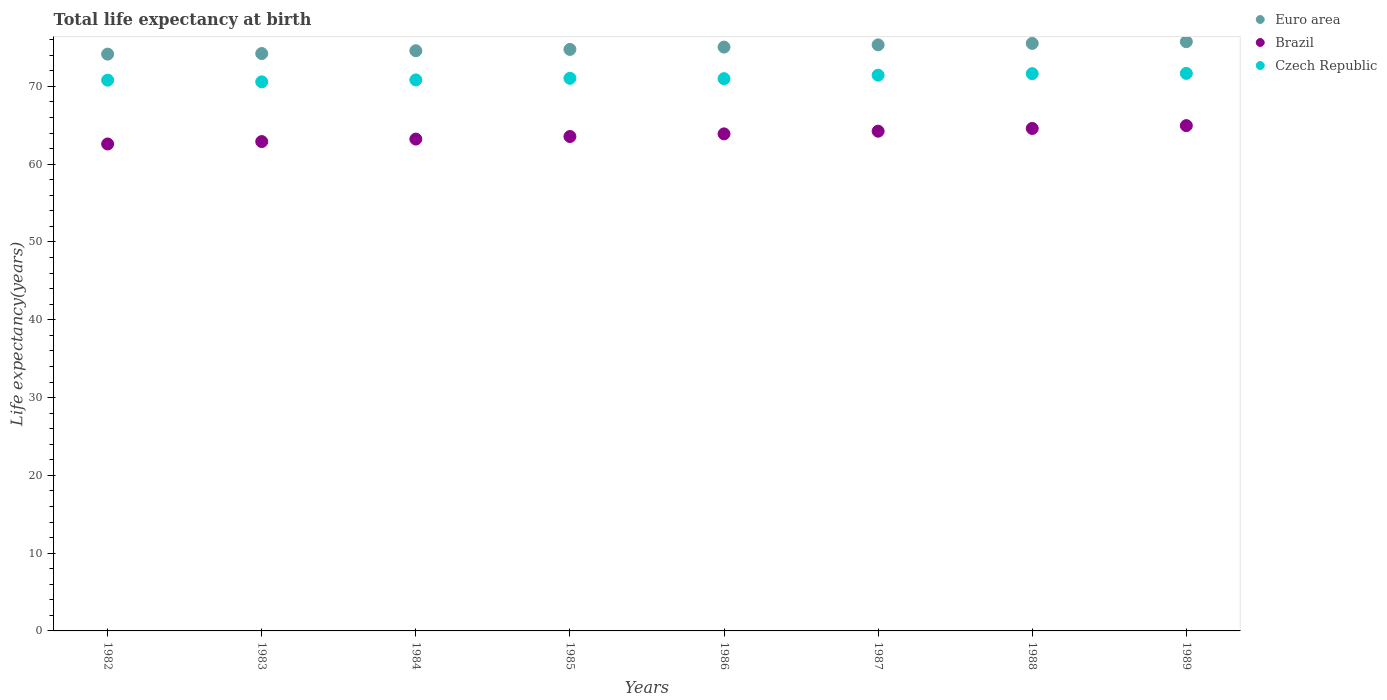How many different coloured dotlines are there?
Give a very brief answer. 3. What is the life expectancy at birth in in Czech Republic in 1989?
Your response must be concise. 71.68. Across all years, what is the maximum life expectancy at birth in in Euro area?
Your answer should be very brief. 75.75. Across all years, what is the minimum life expectancy at birth in in Czech Republic?
Offer a terse response. 70.59. In which year was the life expectancy at birth in in Euro area maximum?
Ensure brevity in your answer.  1989. What is the total life expectancy at birth in in Euro area in the graph?
Give a very brief answer. 599.41. What is the difference between the life expectancy at birth in in Czech Republic in 1982 and that in 1987?
Your answer should be compact. -0.64. What is the difference between the life expectancy at birth in in Czech Republic in 1985 and the life expectancy at birth in in Brazil in 1986?
Offer a terse response. 7.15. What is the average life expectancy at birth in in Czech Republic per year?
Provide a short and direct response. 71.13. In the year 1988, what is the difference between the life expectancy at birth in in Brazil and life expectancy at birth in in Euro area?
Your answer should be very brief. -10.93. What is the ratio of the life expectancy at birth in in Euro area in 1983 to that in 1989?
Ensure brevity in your answer.  0.98. What is the difference between the highest and the second highest life expectancy at birth in in Czech Republic?
Give a very brief answer. 0.03. What is the difference between the highest and the lowest life expectancy at birth in in Czech Republic?
Offer a very short reply. 1.08. In how many years, is the life expectancy at birth in in Czech Republic greater than the average life expectancy at birth in in Czech Republic taken over all years?
Give a very brief answer. 3. Is the sum of the life expectancy at birth in in Brazil in 1984 and 1987 greater than the maximum life expectancy at birth in in Euro area across all years?
Make the answer very short. Yes. How many dotlines are there?
Keep it short and to the point. 3. Are the values on the major ticks of Y-axis written in scientific E-notation?
Your answer should be very brief. No. Does the graph contain any zero values?
Your answer should be very brief. No. Does the graph contain grids?
Provide a short and direct response. No. Where does the legend appear in the graph?
Provide a succinct answer. Top right. How many legend labels are there?
Your answer should be compact. 3. How are the legend labels stacked?
Your answer should be very brief. Vertical. What is the title of the graph?
Your answer should be compact. Total life expectancy at birth. Does "Albania" appear as one of the legend labels in the graph?
Your answer should be compact. No. What is the label or title of the Y-axis?
Provide a short and direct response. Life expectancy(years). What is the Life expectancy(years) of Euro area in 1982?
Your answer should be compact. 74.15. What is the Life expectancy(years) in Brazil in 1982?
Ensure brevity in your answer.  62.6. What is the Life expectancy(years) in Czech Republic in 1982?
Give a very brief answer. 70.81. What is the Life expectancy(years) of Euro area in 1983?
Offer a very short reply. 74.23. What is the Life expectancy(years) in Brazil in 1983?
Ensure brevity in your answer.  62.91. What is the Life expectancy(years) of Czech Republic in 1983?
Provide a succinct answer. 70.59. What is the Life expectancy(years) of Euro area in 1984?
Provide a short and direct response. 74.59. What is the Life expectancy(years) in Brazil in 1984?
Provide a short and direct response. 63.23. What is the Life expectancy(years) of Czech Republic in 1984?
Provide a succinct answer. 70.84. What is the Life expectancy(years) in Euro area in 1985?
Provide a short and direct response. 74.76. What is the Life expectancy(years) of Brazil in 1985?
Offer a very short reply. 63.56. What is the Life expectancy(years) of Czech Republic in 1985?
Keep it short and to the point. 71.05. What is the Life expectancy(years) in Euro area in 1986?
Make the answer very short. 75.06. What is the Life expectancy(years) in Brazil in 1986?
Your response must be concise. 63.9. What is the Life expectancy(years) of Czech Republic in 1986?
Offer a very short reply. 71. What is the Life expectancy(years) of Euro area in 1987?
Your answer should be compact. 75.35. What is the Life expectancy(years) in Brazil in 1987?
Offer a very short reply. 64.25. What is the Life expectancy(years) of Czech Republic in 1987?
Provide a succinct answer. 71.45. What is the Life expectancy(years) in Euro area in 1988?
Offer a terse response. 75.53. What is the Life expectancy(years) of Brazil in 1988?
Ensure brevity in your answer.  64.6. What is the Life expectancy(years) in Czech Republic in 1988?
Your response must be concise. 71.64. What is the Life expectancy(years) in Euro area in 1989?
Offer a very short reply. 75.75. What is the Life expectancy(years) of Brazil in 1989?
Your answer should be compact. 64.96. What is the Life expectancy(years) of Czech Republic in 1989?
Your answer should be compact. 71.68. Across all years, what is the maximum Life expectancy(years) in Euro area?
Make the answer very short. 75.75. Across all years, what is the maximum Life expectancy(years) in Brazil?
Provide a succinct answer. 64.96. Across all years, what is the maximum Life expectancy(years) of Czech Republic?
Keep it short and to the point. 71.68. Across all years, what is the minimum Life expectancy(years) of Euro area?
Provide a succinct answer. 74.15. Across all years, what is the minimum Life expectancy(years) of Brazil?
Keep it short and to the point. 62.6. Across all years, what is the minimum Life expectancy(years) in Czech Republic?
Keep it short and to the point. 70.59. What is the total Life expectancy(years) of Euro area in the graph?
Provide a succinct answer. 599.41. What is the total Life expectancy(years) of Brazil in the graph?
Give a very brief answer. 510.01. What is the total Life expectancy(years) of Czech Republic in the graph?
Provide a succinct answer. 569.04. What is the difference between the Life expectancy(years) of Euro area in 1982 and that in 1983?
Ensure brevity in your answer.  -0.08. What is the difference between the Life expectancy(years) in Brazil in 1982 and that in 1983?
Provide a succinct answer. -0.31. What is the difference between the Life expectancy(years) of Czech Republic in 1982 and that in 1983?
Keep it short and to the point. 0.22. What is the difference between the Life expectancy(years) of Euro area in 1982 and that in 1984?
Give a very brief answer. -0.43. What is the difference between the Life expectancy(years) in Brazil in 1982 and that in 1984?
Keep it short and to the point. -0.63. What is the difference between the Life expectancy(years) of Czech Republic in 1982 and that in 1984?
Your answer should be compact. -0.03. What is the difference between the Life expectancy(years) in Euro area in 1982 and that in 1985?
Provide a succinct answer. -0.6. What is the difference between the Life expectancy(years) in Brazil in 1982 and that in 1985?
Provide a short and direct response. -0.96. What is the difference between the Life expectancy(years) in Czech Republic in 1982 and that in 1985?
Give a very brief answer. -0.24. What is the difference between the Life expectancy(years) of Euro area in 1982 and that in 1986?
Offer a terse response. -0.9. What is the difference between the Life expectancy(years) of Brazil in 1982 and that in 1986?
Your response must be concise. -1.3. What is the difference between the Life expectancy(years) of Czech Republic in 1982 and that in 1986?
Your answer should be very brief. -0.19. What is the difference between the Life expectancy(years) of Euro area in 1982 and that in 1987?
Your answer should be compact. -1.19. What is the difference between the Life expectancy(years) in Brazil in 1982 and that in 1987?
Your answer should be very brief. -1.64. What is the difference between the Life expectancy(years) of Czech Republic in 1982 and that in 1987?
Your answer should be compact. -0.64. What is the difference between the Life expectancy(years) in Euro area in 1982 and that in 1988?
Your answer should be very brief. -1.38. What is the difference between the Life expectancy(years) in Brazil in 1982 and that in 1988?
Ensure brevity in your answer.  -2. What is the difference between the Life expectancy(years) of Czech Republic in 1982 and that in 1988?
Make the answer very short. -0.83. What is the difference between the Life expectancy(years) in Euro area in 1982 and that in 1989?
Provide a short and direct response. -1.6. What is the difference between the Life expectancy(years) in Brazil in 1982 and that in 1989?
Offer a terse response. -2.36. What is the difference between the Life expectancy(years) in Czech Republic in 1982 and that in 1989?
Ensure brevity in your answer.  -0.87. What is the difference between the Life expectancy(years) of Euro area in 1983 and that in 1984?
Your answer should be compact. -0.36. What is the difference between the Life expectancy(years) of Brazil in 1983 and that in 1984?
Offer a terse response. -0.32. What is the difference between the Life expectancy(years) in Czech Republic in 1983 and that in 1984?
Offer a very short reply. -0.25. What is the difference between the Life expectancy(years) of Euro area in 1983 and that in 1985?
Ensure brevity in your answer.  -0.53. What is the difference between the Life expectancy(years) in Brazil in 1983 and that in 1985?
Ensure brevity in your answer.  -0.65. What is the difference between the Life expectancy(years) in Czech Republic in 1983 and that in 1985?
Your response must be concise. -0.45. What is the difference between the Life expectancy(years) in Euro area in 1983 and that in 1986?
Keep it short and to the point. -0.83. What is the difference between the Life expectancy(years) in Brazil in 1983 and that in 1986?
Make the answer very short. -0.99. What is the difference between the Life expectancy(years) in Czech Republic in 1983 and that in 1986?
Ensure brevity in your answer.  -0.41. What is the difference between the Life expectancy(years) of Euro area in 1983 and that in 1987?
Your answer should be very brief. -1.12. What is the difference between the Life expectancy(years) of Brazil in 1983 and that in 1987?
Your answer should be very brief. -1.33. What is the difference between the Life expectancy(years) in Czech Republic in 1983 and that in 1987?
Offer a terse response. -0.85. What is the difference between the Life expectancy(years) in Euro area in 1983 and that in 1988?
Give a very brief answer. -1.3. What is the difference between the Life expectancy(years) in Brazil in 1983 and that in 1988?
Offer a terse response. -1.69. What is the difference between the Life expectancy(years) in Czech Republic in 1983 and that in 1988?
Give a very brief answer. -1.05. What is the difference between the Life expectancy(years) of Euro area in 1983 and that in 1989?
Ensure brevity in your answer.  -1.52. What is the difference between the Life expectancy(years) in Brazil in 1983 and that in 1989?
Keep it short and to the point. -2.05. What is the difference between the Life expectancy(years) of Czech Republic in 1983 and that in 1989?
Ensure brevity in your answer.  -1.08. What is the difference between the Life expectancy(years) in Euro area in 1984 and that in 1985?
Provide a short and direct response. -0.17. What is the difference between the Life expectancy(years) in Brazil in 1984 and that in 1985?
Your answer should be very brief. -0.33. What is the difference between the Life expectancy(years) of Czech Republic in 1984 and that in 1985?
Your response must be concise. -0.21. What is the difference between the Life expectancy(years) of Euro area in 1984 and that in 1986?
Offer a terse response. -0.47. What is the difference between the Life expectancy(years) of Brazil in 1984 and that in 1986?
Ensure brevity in your answer.  -0.67. What is the difference between the Life expectancy(years) of Czech Republic in 1984 and that in 1986?
Give a very brief answer. -0.16. What is the difference between the Life expectancy(years) in Euro area in 1984 and that in 1987?
Make the answer very short. -0.76. What is the difference between the Life expectancy(years) in Brazil in 1984 and that in 1987?
Provide a succinct answer. -1.01. What is the difference between the Life expectancy(years) of Czech Republic in 1984 and that in 1987?
Your answer should be very brief. -0.61. What is the difference between the Life expectancy(years) of Euro area in 1984 and that in 1988?
Ensure brevity in your answer.  -0.94. What is the difference between the Life expectancy(years) in Brazil in 1984 and that in 1988?
Your response must be concise. -1.37. What is the difference between the Life expectancy(years) in Czech Republic in 1984 and that in 1988?
Give a very brief answer. -0.8. What is the difference between the Life expectancy(years) of Euro area in 1984 and that in 1989?
Offer a very short reply. -1.16. What is the difference between the Life expectancy(years) of Brazil in 1984 and that in 1989?
Your answer should be compact. -1.73. What is the difference between the Life expectancy(years) in Czech Republic in 1984 and that in 1989?
Your answer should be very brief. -0.84. What is the difference between the Life expectancy(years) in Euro area in 1985 and that in 1986?
Your answer should be compact. -0.3. What is the difference between the Life expectancy(years) in Brazil in 1985 and that in 1986?
Offer a very short reply. -0.34. What is the difference between the Life expectancy(years) in Czech Republic in 1985 and that in 1986?
Ensure brevity in your answer.  0.05. What is the difference between the Life expectancy(years) in Euro area in 1985 and that in 1987?
Keep it short and to the point. -0.59. What is the difference between the Life expectancy(years) in Brazil in 1985 and that in 1987?
Give a very brief answer. -0.68. What is the difference between the Life expectancy(years) of Czech Republic in 1985 and that in 1987?
Give a very brief answer. -0.4. What is the difference between the Life expectancy(years) in Euro area in 1985 and that in 1988?
Make the answer very short. -0.77. What is the difference between the Life expectancy(years) of Brazil in 1985 and that in 1988?
Make the answer very short. -1.04. What is the difference between the Life expectancy(years) in Czech Republic in 1985 and that in 1988?
Ensure brevity in your answer.  -0.6. What is the difference between the Life expectancy(years) of Euro area in 1985 and that in 1989?
Keep it short and to the point. -0.99. What is the difference between the Life expectancy(years) in Brazil in 1985 and that in 1989?
Ensure brevity in your answer.  -1.4. What is the difference between the Life expectancy(years) in Czech Republic in 1985 and that in 1989?
Your answer should be compact. -0.63. What is the difference between the Life expectancy(years) in Euro area in 1986 and that in 1987?
Provide a short and direct response. -0.29. What is the difference between the Life expectancy(years) in Brazil in 1986 and that in 1987?
Provide a succinct answer. -0.35. What is the difference between the Life expectancy(years) of Czech Republic in 1986 and that in 1987?
Give a very brief answer. -0.45. What is the difference between the Life expectancy(years) in Euro area in 1986 and that in 1988?
Give a very brief answer. -0.47. What is the difference between the Life expectancy(years) in Brazil in 1986 and that in 1988?
Give a very brief answer. -0.7. What is the difference between the Life expectancy(years) of Czech Republic in 1986 and that in 1988?
Your answer should be very brief. -0.64. What is the difference between the Life expectancy(years) of Euro area in 1986 and that in 1989?
Offer a terse response. -0.7. What is the difference between the Life expectancy(years) in Brazil in 1986 and that in 1989?
Your response must be concise. -1.06. What is the difference between the Life expectancy(years) of Czech Republic in 1986 and that in 1989?
Keep it short and to the point. -0.68. What is the difference between the Life expectancy(years) in Euro area in 1987 and that in 1988?
Your answer should be very brief. -0.18. What is the difference between the Life expectancy(years) of Brazil in 1987 and that in 1988?
Your answer should be very brief. -0.35. What is the difference between the Life expectancy(years) in Czech Republic in 1987 and that in 1988?
Your answer should be compact. -0.2. What is the difference between the Life expectancy(years) of Euro area in 1987 and that in 1989?
Ensure brevity in your answer.  -0.41. What is the difference between the Life expectancy(years) in Brazil in 1987 and that in 1989?
Make the answer very short. -0.72. What is the difference between the Life expectancy(years) of Czech Republic in 1987 and that in 1989?
Your answer should be compact. -0.23. What is the difference between the Life expectancy(years) in Euro area in 1988 and that in 1989?
Your answer should be compact. -0.22. What is the difference between the Life expectancy(years) of Brazil in 1988 and that in 1989?
Ensure brevity in your answer.  -0.36. What is the difference between the Life expectancy(years) in Czech Republic in 1988 and that in 1989?
Your answer should be very brief. -0.03. What is the difference between the Life expectancy(years) in Euro area in 1982 and the Life expectancy(years) in Brazil in 1983?
Give a very brief answer. 11.24. What is the difference between the Life expectancy(years) in Euro area in 1982 and the Life expectancy(years) in Czech Republic in 1983?
Provide a short and direct response. 3.56. What is the difference between the Life expectancy(years) in Brazil in 1982 and the Life expectancy(years) in Czech Republic in 1983?
Keep it short and to the point. -7.99. What is the difference between the Life expectancy(years) of Euro area in 1982 and the Life expectancy(years) of Brazil in 1984?
Provide a succinct answer. 10.92. What is the difference between the Life expectancy(years) in Euro area in 1982 and the Life expectancy(years) in Czech Republic in 1984?
Make the answer very short. 3.32. What is the difference between the Life expectancy(years) of Brazil in 1982 and the Life expectancy(years) of Czech Republic in 1984?
Provide a succinct answer. -8.24. What is the difference between the Life expectancy(years) in Euro area in 1982 and the Life expectancy(years) in Brazil in 1985?
Ensure brevity in your answer.  10.59. What is the difference between the Life expectancy(years) of Euro area in 1982 and the Life expectancy(years) of Czech Republic in 1985?
Give a very brief answer. 3.11. What is the difference between the Life expectancy(years) of Brazil in 1982 and the Life expectancy(years) of Czech Republic in 1985?
Keep it short and to the point. -8.44. What is the difference between the Life expectancy(years) of Euro area in 1982 and the Life expectancy(years) of Brazil in 1986?
Keep it short and to the point. 10.25. What is the difference between the Life expectancy(years) of Euro area in 1982 and the Life expectancy(years) of Czech Republic in 1986?
Your answer should be compact. 3.16. What is the difference between the Life expectancy(years) in Brazil in 1982 and the Life expectancy(years) in Czech Republic in 1986?
Give a very brief answer. -8.4. What is the difference between the Life expectancy(years) in Euro area in 1982 and the Life expectancy(years) in Brazil in 1987?
Make the answer very short. 9.91. What is the difference between the Life expectancy(years) in Euro area in 1982 and the Life expectancy(years) in Czech Republic in 1987?
Provide a succinct answer. 2.71. What is the difference between the Life expectancy(years) in Brazil in 1982 and the Life expectancy(years) in Czech Republic in 1987?
Ensure brevity in your answer.  -8.84. What is the difference between the Life expectancy(years) of Euro area in 1982 and the Life expectancy(years) of Brazil in 1988?
Provide a succinct answer. 9.56. What is the difference between the Life expectancy(years) in Euro area in 1982 and the Life expectancy(years) in Czech Republic in 1988?
Make the answer very short. 2.51. What is the difference between the Life expectancy(years) in Brazil in 1982 and the Life expectancy(years) in Czech Republic in 1988?
Give a very brief answer. -9.04. What is the difference between the Life expectancy(years) in Euro area in 1982 and the Life expectancy(years) in Brazil in 1989?
Offer a very short reply. 9.19. What is the difference between the Life expectancy(years) in Euro area in 1982 and the Life expectancy(years) in Czech Republic in 1989?
Your response must be concise. 2.48. What is the difference between the Life expectancy(years) of Brazil in 1982 and the Life expectancy(years) of Czech Republic in 1989?
Provide a succinct answer. -9.07. What is the difference between the Life expectancy(years) in Euro area in 1983 and the Life expectancy(years) in Brazil in 1984?
Give a very brief answer. 11. What is the difference between the Life expectancy(years) of Euro area in 1983 and the Life expectancy(years) of Czech Republic in 1984?
Keep it short and to the point. 3.39. What is the difference between the Life expectancy(years) in Brazil in 1983 and the Life expectancy(years) in Czech Republic in 1984?
Keep it short and to the point. -7.93. What is the difference between the Life expectancy(years) in Euro area in 1983 and the Life expectancy(years) in Brazil in 1985?
Ensure brevity in your answer.  10.67. What is the difference between the Life expectancy(years) of Euro area in 1983 and the Life expectancy(years) of Czech Republic in 1985?
Offer a very short reply. 3.18. What is the difference between the Life expectancy(years) of Brazil in 1983 and the Life expectancy(years) of Czech Republic in 1985?
Offer a very short reply. -8.13. What is the difference between the Life expectancy(years) in Euro area in 1983 and the Life expectancy(years) in Brazil in 1986?
Your answer should be compact. 10.33. What is the difference between the Life expectancy(years) of Euro area in 1983 and the Life expectancy(years) of Czech Republic in 1986?
Give a very brief answer. 3.23. What is the difference between the Life expectancy(years) of Brazil in 1983 and the Life expectancy(years) of Czech Republic in 1986?
Your response must be concise. -8.09. What is the difference between the Life expectancy(years) of Euro area in 1983 and the Life expectancy(years) of Brazil in 1987?
Ensure brevity in your answer.  9.98. What is the difference between the Life expectancy(years) of Euro area in 1983 and the Life expectancy(years) of Czech Republic in 1987?
Ensure brevity in your answer.  2.78. What is the difference between the Life expectancy(years) of Brazil in 1983 and the Life expectancy(years) of Czech Republic in 1987?
Your answer should be very brief. -8.53. What is the difference between the Life expectancy(years) in Euro area in 1983 and the Life expectancy(years) in Brazil in 1988?
Your answer should be compact. 9.63. What is the difference between the Life expectancy(years) of Euro area in 1983 and the Life expectancy(years) of Czech Republic in 1988?
Offer a very short reply. 2.59. What is the difference between the Life expectancy(years) of Brazil in 1983 and the Life expectancy(years) of Czech Republic in 1988?
Make the answer very short. -8.73. What is the difference between the Life expectancy(years) in Euro area in 1983 and the Life expectancy(years) in Brazil in 1989?
Make the answer very short. 9.27. What is the difference between the Life expectancy(years) of Euro area in 1983 and the Life expectancy(years) of Czech Republic in 1989?
Give a very brief answer. 2.55. What is the difference between the Life expectancy(years) in Brazil in 1983 and the Life expectancy(years) in Czech Republic in 1989?
Offer a terse response. -8.76. What is the difference between the Life expectancy(years) of Euro area in 1984 and the Life expectancy(years) of Brazil in 1985?
Provide a succinct answer. 11.03. What is the difference between the Life expectancy(years) in Euro area in 1984 and the Life expectancy(years) in Czech Republic in 1985?
Provide a short and direct response. 3.54. What is the difference between the Life expectancy(years) of Brazil in 1984 and the Life expectancy(years) of Czech Republic in 1985?
Give a very brief answer. -7.81. What is the difference between the Life expectancy(years) in Euro area in 1984 and the Life expectancy(years) in Brazil in 1986?
Offer a very short reply. 10.69. What is the difference between the Life expectancy(years) of Euro area in 1984 and the Life expectancy(years) of Czech Republic in 1986?
Give a very brief answer. 3.59. What is the difference between the Life expectancy(years) of Brazil in 1984 and the Life expectancy(years) of Czech Republic in 1986?
Ensure brevity in your answer.  -7.77. What is the difference between the Life expectancy(years) in Euro area in 1984 and the Life expectancy(years) in Brazil in 1987?
Provide a short and direct response. 10.34. What is the difference between the Life expectancy(years) in Euro area in 1984 and the Life expectancy(years) in Czech Republic in 1987?
Make the answer very short. 3.14. What is the difference between the Life expectancy(years) in Brazil in 1984 and the Life expectancy(years) in Czech Republic in 1987?
Offer a terse response. -8.21. What is the difference between the Life expectancy(years) of Euro area in 1984 and the Life expectancy(years) of Brazil in 1988?
Your response must be concise. 9.99. What is the difference between the Life expectancy(years) of Euro area in 1984 and the Life expectancy(years) of Czech Republic in 1988?
Make the answer very short. 2.95. What is the difference between the Life expectancy(years) in Brazil in 1984 and the Life expectancy(years) in Czech Republic in 1988?
Your response must be concise. -8.41. What is the difference between the Life expectancy(years) of Euro area in 1984 and the Life expectancy(years) of Brazil in 1989?
Offer a very short reply. 9.63. What is the difference between the Life expectancy(years) in Euro area in 1984 and the Life expectancy(years) in Czech Republic in 1989?
Provide a succinct answer. 2.91. What is the difference between the Life expectancy(years) in Brazil in 1984 and the Life expectancy(years) in Czech Republic in 1989?
Make the answer very short. -8.44. What is the difference between the Life expectancy(years) in Euro area in 1985 and the Life expectancy(years) in Brazil in 1986?
Your answer should be compact. 10.86. What is the difference between the Life expectancy(years) of Euro area in 1985 and the Life expectancy(years) of Czech Republic in 1986?
Your answer should be very brief. 3.76. What is the difference between the Life expectancy(years) of Brazil in 1985 and the Life expectancy(years) of Czech Republic in 1986?
Provide a succinct answer. -7.43. What is the difference between the Life expectancy(years) of Euro area in 1985 and the Life expectancy(years) of Brazil in 1987?
Offer a terse response. 10.51. What is the difference between the Life expectancy(years) in Euro area in 1985 and the Life expectancy(years) in Czech Republic in 1987?
Make the answer very short. 3.31. What is the difference between the Life expectancy(years) in Brazil in 1985 and the Life expectancy(years) in Czech Republic in 1987?
Give a very brief answer. -7.88. What is the difference between the Life expectancy(years) of Euro area in 1985 and the Life expectancy(years) of Brazil in 1988?
Make the answer very short. 10.16. What is the difference between the Life expectancy(years) of Euro area in 1985 and the Life expectancy(years) of Czech Republic in 1988?
Give a very brief answer. 3.12. What is the difference between the Life expectancy(years) in Brazil in 1985 and the Life expectancy(years) in Czech Republic in 1988?
Keep it short and to the point. -8.08. What is the difference between the Life expectancy(years) of Euro area in 1985 and the Life expectancy(years) of Brazil in 1989?
Ensure brevity in your answer.  9.8. What is the difference between the Life expectancy(years) of Euro area in 1985 and the Life expectancy(years) of Czech Republic in 1989?
Your response must be concise. 3.08. What is the difference between the Life expectancy(years) of Brazil in 1985 and the Life expectancy(years) of Czech Republic in 1989?
Your response must be concise. -8.11. What is the difference between the Life expectancy(years) in Euro area in 1986 and the Life expectancy(years) in Brazil in 1987?
Ensure brevity in your answer.  10.81. What is the difference between the Life expectancy(years) in Euro area in 1986 and the Life expectancy(years) in Czech Republic in 1987?
Your answer should be very brief. 3.61. What is the difference between the Life expectancy(years) in Brazil in 1986 and the Life expectancy(years) in Czech Republic in 1987?
Give a very brief answer. -7.55. What is the difference between the Life expectancy(years) in Euro area in 1986 and the Life expectancy(years) in Brazil in 1988?
Your answer should be compact. 10.46. What is the difference between the Life expectancy(years) in Euro area in 1986 and the Life expectancy(years) in Czech Republic in 1988?
Offer a terse response. 3.42. What is the difference between the Life expectancy(years) in Brazil in 1986 and the Life expectancy(years) in Czech Republic in 1988?
Provide a short and direct response. -7.74. What is the difference between the Life expectancy(years) of Euro area in 1986 and the Life expectancy(years) of Brazil in 1989?
Give a very brief answer. 10.1. What is the difference between the Life expectancy(years) of Euro area in 1986 and the Life expectancy(years) of Czech Republic in 1989?
Ensure brevity in your answer.  3.38. What is the difference between the Life expectancy(years) in Brazil in 1986 and the Life expectancy(years) in Czech Republic in 1989?
Provide a short and direct response. -7.78. What is the difference between the Life expectancy(years) of Euro area in 1987 and the Life expectancy(years) of Brazil in 1988?
Your response must be concise. 10.75. What is the difference between the Life expectancy(years) in Euro area in 1987 and the Life expectancy(years) in Czech Republic in 1988?
Offer a terse response. 3.7. What is the difference between the Life expectancy(years) in Brazil in 1987 and the Life expectancy(years) in Czech Republic in 1988?
Your answer should be very brief. -7.4. What is the difference between the Life expectancy(years) in Euro area in 1987 and the Life expectancy(years) in Brazil in 1989?
Your response must be concise. 10.38. What is the difference between the Life expectancy(years) of Euro area in 1987 and the Life expectancy(years) of Czech Republic in 1989?
Provide a succinct answer. 3.67. What is the difference between the Life expectancy(years) of Brazil in 1987 and the Life expectancy(years) of Czech Republic in 1989?
Provide a succinct answer. -7.43. What is the difference between the Life expectancy(years) in Euro area in 1988 and the Life expectancy(years) in Brazil in 1989?
Make the answer very short. 10.57. What is the difference between the Life expectancy(years) in Euro area in 1988 and the Life expectancy(years) in Czech Republic in 1989?
Make the answer very short. 3.85. What is the difference between the Life expectancy(years) in Brazil in 1988 and the Life expectancy(years) in Czech Republic in 1989?
Offer a terse response. -7.08. What is the average Life expectancy(years) in Euro area per year?
Your answer should be compact. 74.93. What is the average Life expectancy(years) in Brazil per year?
Your answer should be very brief. 63.75. What is the average Life expectancy(years) of Czech Republic per year?
Make the answer very short. 71.13. In the year 1982, what is the difference between the Life expectancy(years) of Euro area and Life expectancy(years) of Brazil?
Your answer should be very brief. 11.55. In the year 1982, what is the difference between the Life expectancy(years) of Euro area and Life expectancy(years) of Czech Republic?
Offer a very short reply. 3.35. In the year 1982, what is the difference between the Life expectancy(years) of Brazil and Life expectancy(years) of Czech Republic?
Provide a succinct answer. -8.21. In the year 1983, what is the difference between the Life expectancy(years) in Euro area and Life expectancy(years) in Brazil?
Your response must be concise. 11.32. In the year 1983, what is the difference between the Life expectancy(years) of Euro area and Life expectancy(years) of Czech Republic?
Give a very brief answer. 3.64. In the year 1983, what is the difference between the Life expectancy(years) of Brazil and Life expectancy(years) of Czech Republic?
Give a very brief answer. -7.68. In the year 1984, what is the difference between the Life expectancy(years) in Euro area and Life expectancy(years) in Brazil?
Make the answer very short. 11.36. In the year 1984, what is the difference between the Life expectancy(years) of Euro area and Life expectancy(years) of Czech Republic?
Give a very brief answer. 3.75. In the year 1984, what is the difference between the Life expectancy(years) in Brazil and Life expectancy(years) in Czech Republic?
Provide a short and direct response. -7.61. In the year 1985, what is the difference between the Life expectancy(years) in Euro area and Life expectancy(years) in Brazil?
Ensure brevity in your answer.  11.2. In the year 1985, what is the difference between the Life expectancy(years) of Euro area and Life expectancy(years) of Czech Republic?
Offer a terse response. 3.71. In the year 1985, what is the difference between the Life expectancy(years) in Brazil and Life expectancy(years) in Czech Republic?
Offer a very short reply. -7.48. In the year 1986, what is the difference between the Life expectancy(years) of Euro area and Life expectancy(years) of Brazil?
Make the answer very short. 11.16. In the year 1986, what is the difference between the Life expectancy(years) in Euro area and Life expectancy(years) in Czech Republic?
Make the answer very short. 4.06. In the year 1986, what is the difference between the Life expectancy(years) of Brazil and Life expectancy(years) of Czech Republic?
Offer a terse response. -7.1. In the year 1987, what is the difference between the Life expectancy(years) in Euro area and Life expectancy(years) in Brazil?
Your answer should be very brief. 11.1. In the year 1987, what is the difference between the Life expectancy(years) of Euro area and Life expectancy(years) of Czech Republic?
Make the answer very short. 3.9. In the year 1987, what is the difference between the Life expectancy(years) in Brazil and Life expectancy(years) in Czech Republic?
Provide a succinct answer. -7.2. In the year 1988, what is the difference between the Life expectancy(years) of Euro area and Life expectancy(years) of Brazil?
Your answer should be compact. 10.93. In the year 1988, what is the difference between the Life expectancy(years) of Euro area and Life expectancy(years) of Czech Republic?
Offer a very short reply. 3.89. In the year 1988, what is the difference between the Life expectancy(years) in Brazil and Life expectancy(years) in Czech Republic?
Your answer should be very brief. -7.04. In the year 1989, what is the difference between the Life expectancy(years) in Euro area and Life expectancy(years) in Brazil?
Keep it short and to the point. 10.79. In the year 1989, what is the difference between the Life expectancy(years) in Euro area and Life expectancy(years) in Czech Republic?
Ensure brevity in your answer.  4.08. In the year 1989, what is the difference between the Life expectancy(years) in Brazil and Life expectancy(years) in Czech Republic?
Offer a very short reply. -6.71. What is the ratio of the Life expectancy(years) of Brazil in 1982 to that in 1983?
Your answer should be compact. 1. What is the ratio of the Life expectancy(years) in Euro area in 1982 to that in 1984?
Your response must be concise. 0.99. What is the ratio of the Life expectancy(years) in Brazil in 1982 to that in 1984?
Make the answer very short. 0.99. What is the ratio of the Life expectancy(years) of Czech Republic in 1982 to that in 1984?
Provide a succinct answer. 1. What is the ratio of the Life expectancy(years) of Brazil in 1982 to that in 1985?
Your response must be concise. 0.98. What is the ratio of the Life expectancy(years) of Brazil in 1982 to that in 1986?
Your response must be concise. 0.98. What is the ratio of the Life expectancy(years) of Czech Republic in 1982 to that in 1986?
Provide a short and direct response. 1. What is the ratio of the Life expectancy(years) in Euro area in 1982 to that in 1987?
Your answer should be very brief. 0.98. What is the ratio of the Life expectancy(years) of Brazil in 1982 to that in 1987?
Make the answer very short. 0.97. What is the ratio of the Life expectancy(years) of Czech Republic in 1982 to that in 1987?
Offer a very short reply. 0.99. What is the ratio of the Life expectancy(years) in Euro area in 1982 to that in 1988?
Your answer should be compact. 0.98. What is the ratio of the Life expectancy(years) of Brazil in 1982 to that in 1988?
Your response must be concise. 0.97. What is the ratio of the Life expectancy(years) of Czech Republic in 1982 to that in 1988?
Offer a very short reply. 0.99. What is the ratio of the Life expectancy(years) of Euro area in 1982 to that in 1989?
Give a very brief answer. 0.98. What is the ratio of the Life expectancy(years) in Brazil in 1982 to that in 1989?
Ensure brevity in your answer.  0.96. What is the ratio of the Life expectancy(years) in Czech Republic in 1982 to that in 1989?
Make the answer very short. 0.99. What is the ratio of the Life expectancy(years) of Brazil in 1983 to that in 1984?
Make the answer very short. 0.99. What is the ratio of the Life expectancy(years) in Czech Republic in 1983 to that in 1984?
Give a very brief answer. 1. What is the ratio of the Life expectancy(years) in Czech Republic in 1983 to that in 1985?
Your response must be concise. 0.99. What is the ratio of the Life expectancy(years) in Brazil in 1983 to that in 1986?
Offer a terse response. 0.98. What is the ratio of the Life expectancy(years) of Czech Republic in 1983 to that in 1986?
Give a very brief answer. 0.99. What is the ratio of the Life expectancy(years) in Euro area in 1983 to that in 1987?
Your answer should be compact. 0.99. What is the ratio of the Life expectancy(years) of Brazil in 1983 to that in 1987?
Your response must be concise. 0.98. What is the ratio of the Life expectancy(years) of Euro area in 1983 to that in 1988?
Make the answer very short. 0.98. What is the ratio of the Life expectancy(years) of Brazil in 1983 to that in 1988?
Provide a short and direct response. 0.97. What is the ratio of the Life expectancy(years) of Czech Republic in 1983 to that in 1988?
Offer a terse response. 0.99. What is the ratio of the Life expectancy(years) of Euro area in 1983 to that in 1989?
Your answer should be very brief. 0.98. What is the ratio of the Life expectancy(years) in Brazil in 1983 to that in 1989?
Your answer should be compact. 0.97. What is the ratio of the Life expectancy(years) in Czech Republic in 1983 to that in 1989?
Give a very brief answer. 0.98. What is the ratio of the Life expectancy(years) in Euro area in 1984 to that in 1985?
Give a very brief answer. 1. What is the ratio of the Life expectancy(years) of Brazil in 1984 to that in 1985?
Offer a very short reply. 0.99. What is the ratio of the Life expectancy(years) in Brazil in 1984 to that in 1986?
Your answer should be very brief. 0.99. What is the ratio of the Life expectancy(years) of Brazil in 1984 to that in 1987?
Ensure brevity in your answer.  0.98. What is the ratio of the Life expectancy(years) in Euro area in 1984 to that in 1988?
Your response must be concise. 0.99. What is the ratio of the Life expectancy(years) in Brazil in 1984 to that in 1988?
Offer a very short reply. 0.98. What is the ratio of the Life expectancy(years) of Euro area in 1984 to that in 1989?
Offer a terse response. 0.98. What is the ratio of the Life expectancy(years) in Brazil in 1984 to that in 1989?
Offer a terse response. 0.97. What is the ratio of the Life expectancy(years) in Czech Republic in 1984 to that in 1989?
Give a very brief answer. 0.99. What is the ratio of the Life expectancy(years) of Euro area in 1985 to that in 1986?
Your answer should be compact. 1. What is the ratio of the Life expectancy(years) of Brazil in 1985 to that in 1986?
Make the answer very short. 0.99. What is the ratio of the Life expectancy(years) of Brazil in 1985 to that in 1987?
Give a very brief answer. 0.99. What is the ratio of the Life expectancy(years) of Euro area in 1985 to that in 1988?
Your answer should be very brief. 0.99. What is the ratio of the Life expectancy(years) of Brazil in 1985 to that in 1988?
Give a very brief answer. 0.98. What is the ratio of the Life expectancy(years) of Euro area in 1985 to that in 1989?
Offer a terse response. 0.99. What is the ratio of the Life expectancy(years) of Brazil in 1985 to that in 1989?
Make the answer very short. 0.98. What is the ratio of the Life expectancy(years) in Czech Republic in 1985 to that in 1989?
Provide a succinct answer. 0.99. What is the ratio of the Life expectancy(years) of Brazil in 1986 to that in 1987?
Your response must be concise. 0.99. What is the ratio of the Life expectancy(years) in Euro area in 1986 to that in 1988?
Provide a succinct answer. 0.99. What is the ratio of the Life expectancy(years) in Brazil in 1986 to that in 1988?
Make the answer very short. 0.99. What is the ratio of the Life expectancy(years) of Brazil in 1986 to that in 1989?
Your response must be concise. 0.98. What is the ratio of the Life expectancy(years) of Brazil in 1987 to that in 1988?
Your answer should be compact. 0.99. What is the ratio of the Life expectancy(years) in Czech Republic in 1987 to that in 1988?
Your answer should be very brief. 1. What is the ratio of the Life expectancy(years) in Brazil in 1987 to that in 1989?
Provide a succinct answer. 0.99. What is the ratio of the Life expectancy(years) in Czech Republic in 1987 to that in 1989?
Provide a succinct answer. 1. What is the ratio of the Life expectancy(years) in Euro area in 1988 to that in 1989?
Your answer should be very brief. 1. What is the difference between the highest and the second highest Life expectancy(years) of Euro area?
Give a very brief answer. 0.22. What is the difference between the highest and the second highest Life expectancy(years) in Brazil?
Make the answer very short. 0.36. What is the difference between the highest and the second highest Life expectancy(years) in Czech Republic?
Keep it short and to the point. 0.03. What is the difference between the highest and the lowest Life expectancy(years) in Euro area?
Offer a terse response. 1.6. What is the difference between the highest and the lowest Life expectancy(years) of Brazil?
Provide a short and direct response. 2.36. What is the difference between the highest and the lowest Life expectancy(years) of Czech Republic?
Make the answer very short. 1.08. 